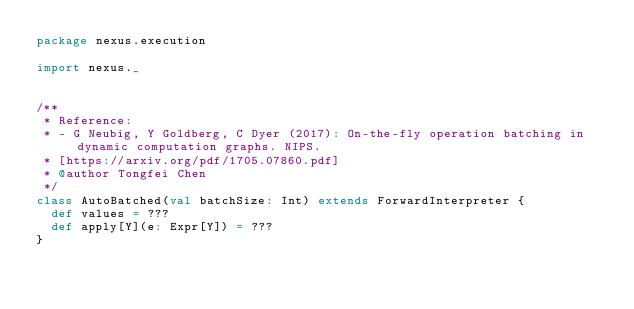Convert code to text. <code><loc_0><loc_0><loc_500><loc_500><_Scala_>package nexus.execution

import nexus._


/**
 * Reference:
 * - G Neubig, Y Goldberg, C Dyer (2017): On-the-fly operation batching in dynamic computation graphs. NIPS.
 * [https://arxiv.org/pdf/1705.07860.pdf]
 * @author Tongfei Chen
 */
class AutoBatched(val batchSize: Int) extends ForwardInterpreter {
  def values = ???
  def apply[Y](e: Expr[Y]) = ???
}
</code> 